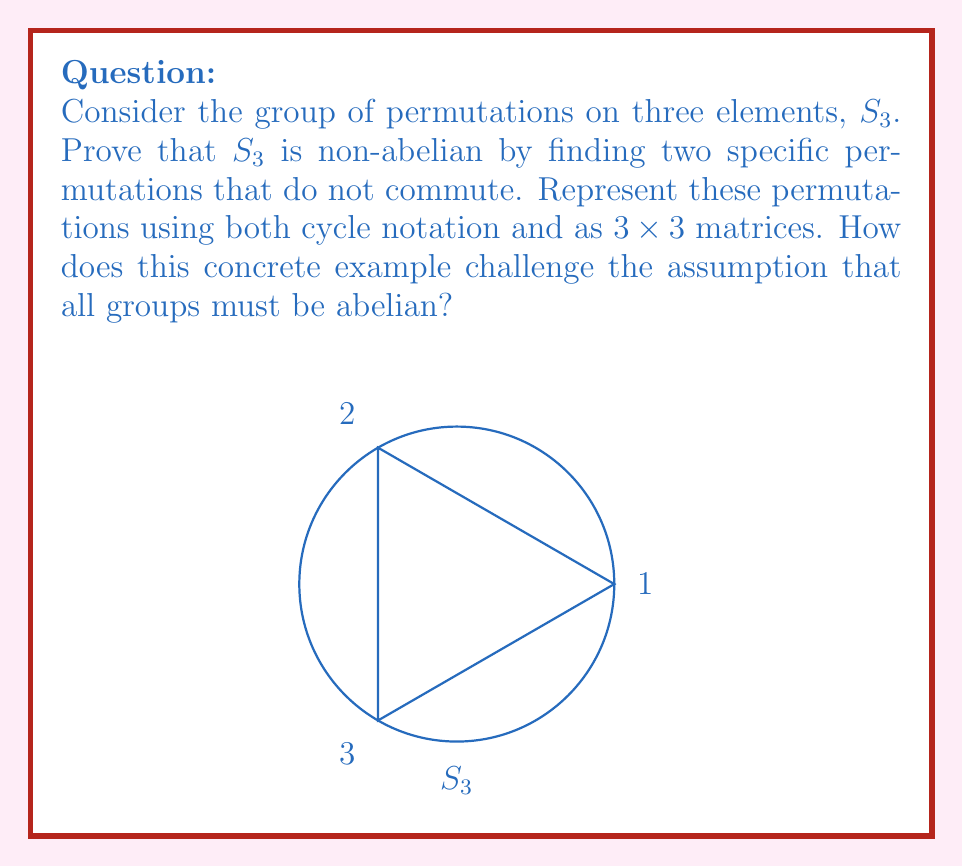Can you answer this question? Let's approach this step-by-step:

1) First, we need to understand what $S_3$ represents. It's the group of all permutations on three elements, usually denoted as {1, 2, 3}.

2) To prove $S_3$ is non-abelian, we need to find two permutations $a$ and $b$ such that $ab \neq ba$.

3) Let's choose two specific permutations:
   $a = (1 2)$ (swaps 1 and 2, leaves 3 fixed)
   $b = (2 3)$ (swaps 2 and 3, leaves 1 fixed)

4) Now, let's compute $ab$ and $ba$:
   $ab = (1 2)(2 3) = (1 3 2)$
   $ba = (2 3)(1 2) = (1 2 3)$

5) Clearly, $ab \neq ba$, which proves that $S_3$ is non-abelian.

6) To represent these as matrices, we can use permutation matrices:

   $a = \begin{pmatrix} 0 & 1 & 0 \\ 1 & 0 & 0 \\ 0 & 0 & 1 \end{pmatrix}$

   $b = \begin{pmatrix} 1 & 0 & 0 \\ 0 & 0 & 1 \\ 0 & 1 & 0 \end{pmatrix}$

7) This concrete example challenges the assumption that all groups must be abelian by providing a clear counterexample. It shows that even in a relatively simple group (with only 6 elements), the commutative property does not always hold.

8) From a skeptical perspective, this demonstrates the importance of not assuming properties without proof, even for seemingly simple mathematical structures.
Answer: $S_3$ is non-abelian: $(1 2)(2 3) = (1 3 2) \neq (1 2 3) = (2 3)(1 2)$ 